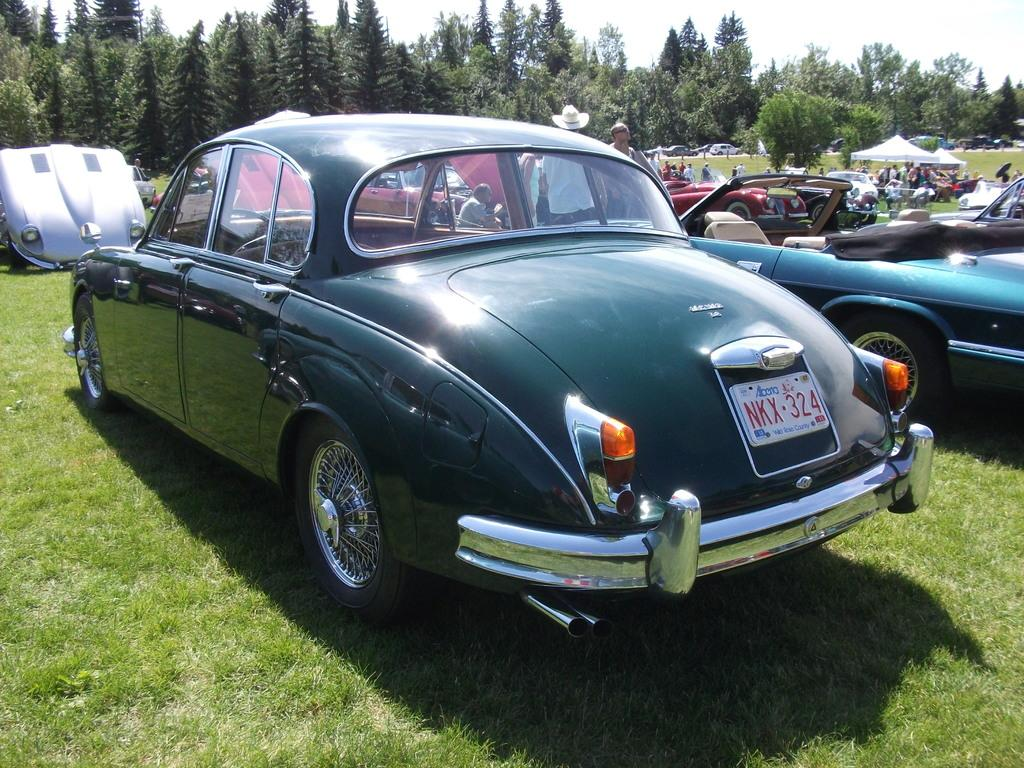What is located on the grass in the image? There are vehicles on the grass in the image. What can be observed about the people in the image? There are people with different color dresses in the image. What structures are visible in the background of the image? There are tents in the background of the image. What type of natural environment is visible in the background of the image? There are many trees in the background of the image. What is visible in the sky in the image? The sky is visible in the background of the image. What color is the brain of the person in the image? There is no brain visible in the image; it is a scene with vehicles, people, tents, trees, and the sky. Can you tell me how many mothers are present in the image? There is no mention of mothers in the image; it features people with different color dresses. 